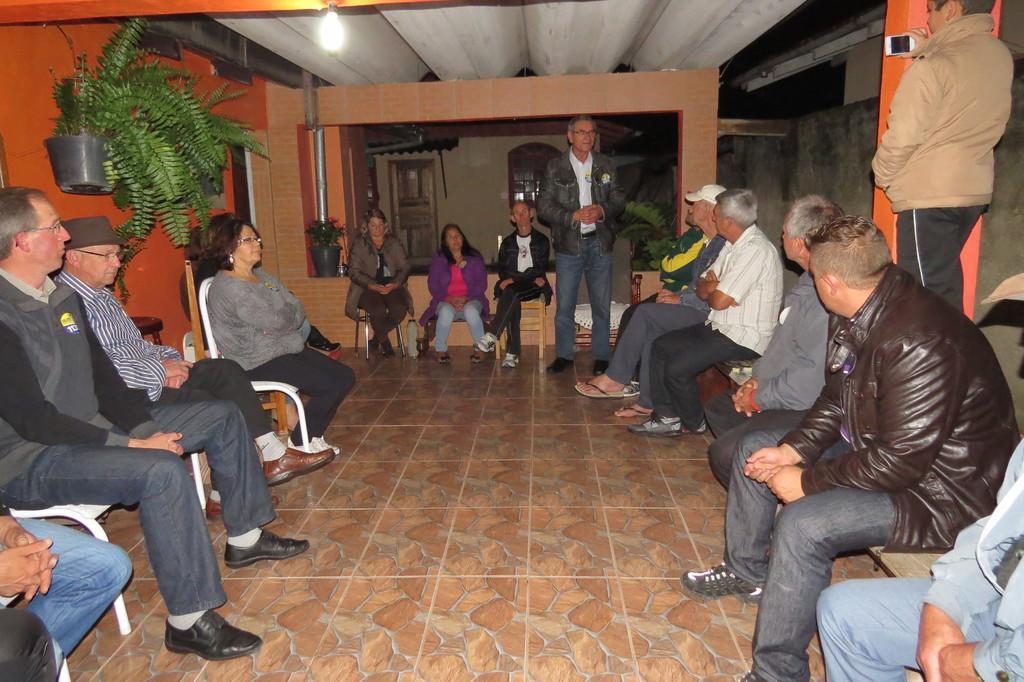How would you summarize this image in a sentence or two? In this image we can see a group of people sitting on the chairs. Here we can see a man standing on the floor. He is wearing a jacket. Here we can see the people who are sitting on the chairs are paying attention to the man who is standing on the floor. Here we can see a man on the top right side and he is holding a mobile phone in his hand. Here we can see the clay pots. Here we can see a lamp on the roof. 